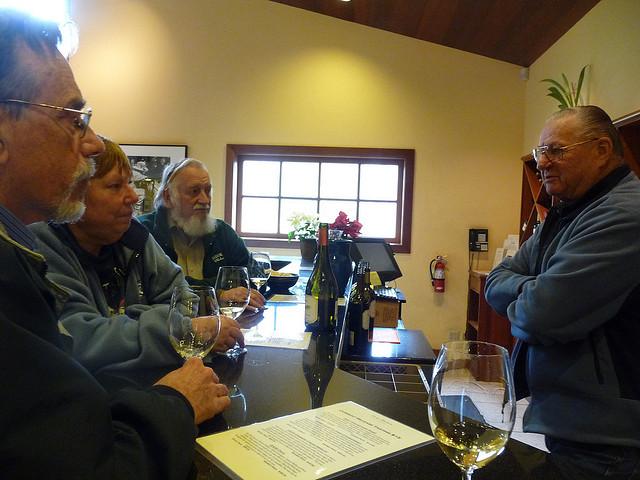Are this people old?
Be succinct. Yes. Is this a wine tasting?
Short answer required. Yes. What are the people waiting for?
Give a very brief answer. Wine. What kind of glasses are these?
Concise answer only. Wine. 